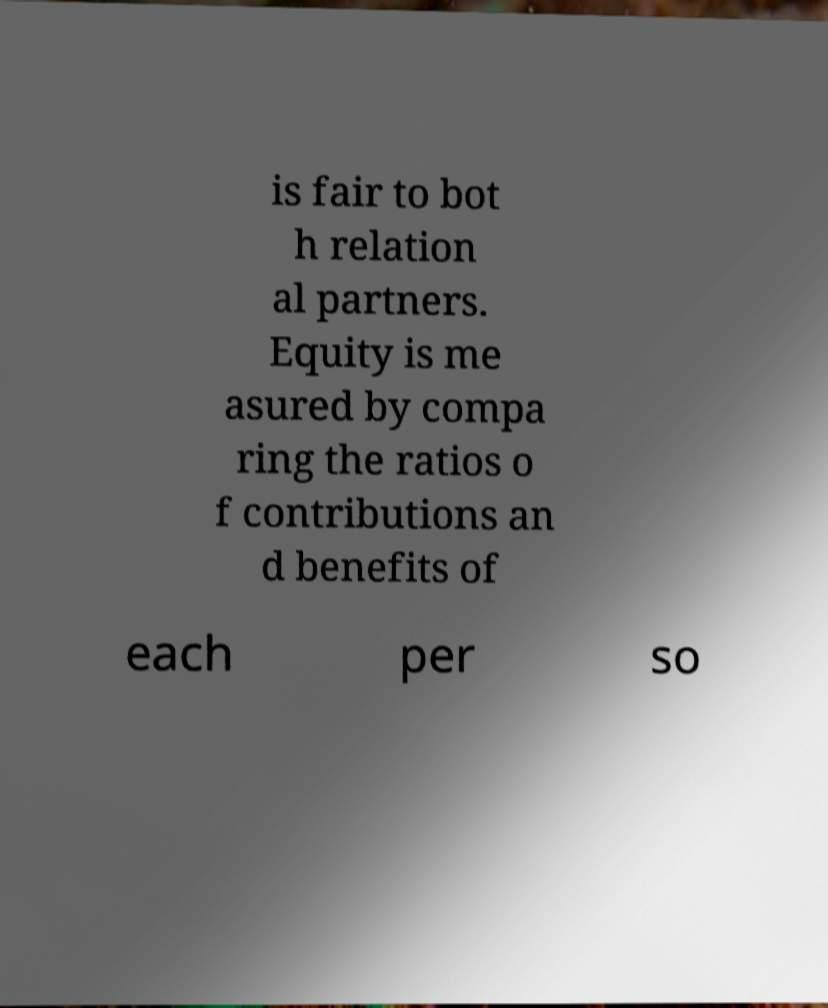I need the written content from this picture converted into text. Can you do that? is fair to bot h relation al partners. Equity is me asured by compa ring the ratios o f contributions an d benefits of each per so 